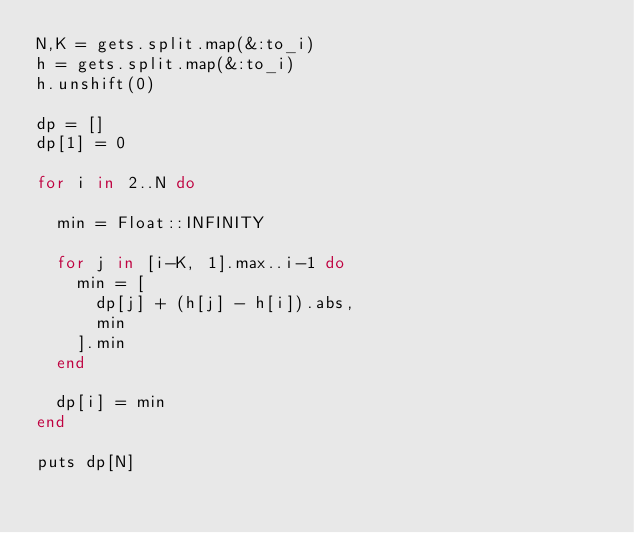Convert code to text. <code><loc_0><loc_0><loc_500><loc_500><_Ruby_>N,K = gets.split.map(&:to_i)
h = gets.split.map(&:to_i)
h.unshift(0)

dp = []
dp[1] = 0

for i in 2..N do

  min = Float::INFINITY

  for j in [i-K, 1].max..i-1 do
    min = [
      dp[j] + (h[j] - h[i]).abs,
      min
    ].min
  end

  dp[i] = min
end

puts dp[N]
</code> 